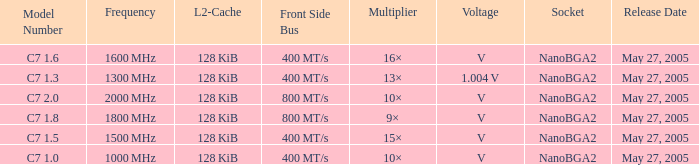What is the Frequency for Model Number c7 1.0? 1000 MHz. 